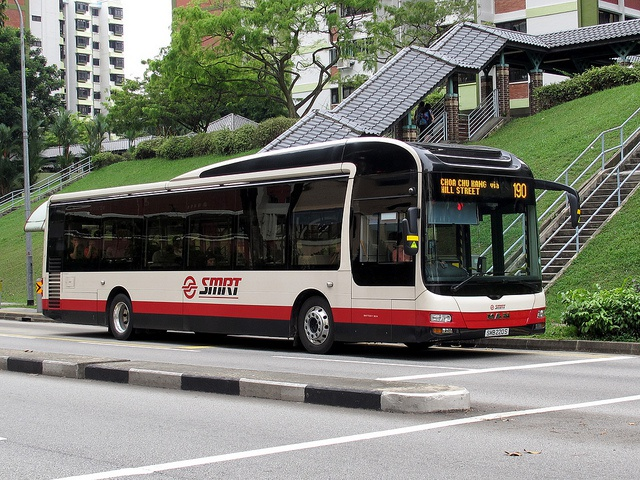Describe the objects in this image and their specific colors. I can see bus in gray, black, lightgray, and brown tones, people in gray, black, navy, and blue tones, people in black, maroon, and gray tones, people in black, maroon, and gray tones, and people in black and gray tones in this image. 